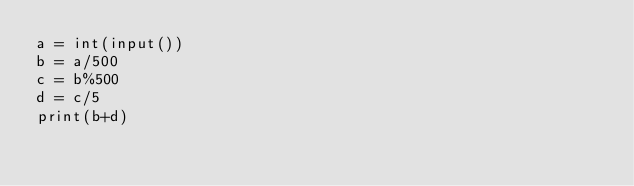<code> <loc_0><loc_0><loc_500><loc_500><_Python_>a = int(input())
b = a/500
c = b%500
d = c/5
print(b+d)</code> 